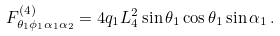Convert formula to latex. <formula><loc_0><loc_0><loc_500><loc_500>F ^ { ( 4 ) } _ { \theta _ { 1 } \phi _ { 1 } \alpha _ { 1 } \alpha _ { 2 } } = 4 { q } _ { 1 } L _ { 4 } ^ { 2 } \sin \theta _ { 1 } \cos \theta _ { 1 } \sin \alpha _ { 1 } \, .</formula> 